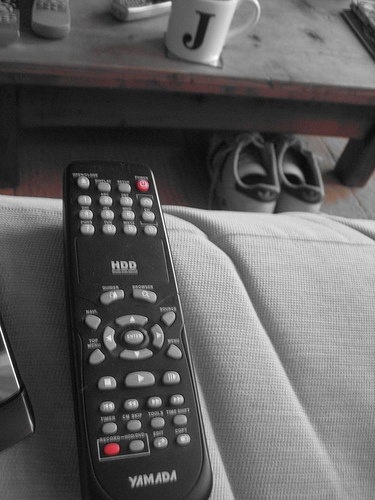Describe the objects in this image and their specific colors. I can see couch in gray, darkgray, black, and lightgray tones, remote in gray, black, darkgray, and lightgray tones, and cup in gray, darkgray, lightgray, and black tones in this image. 